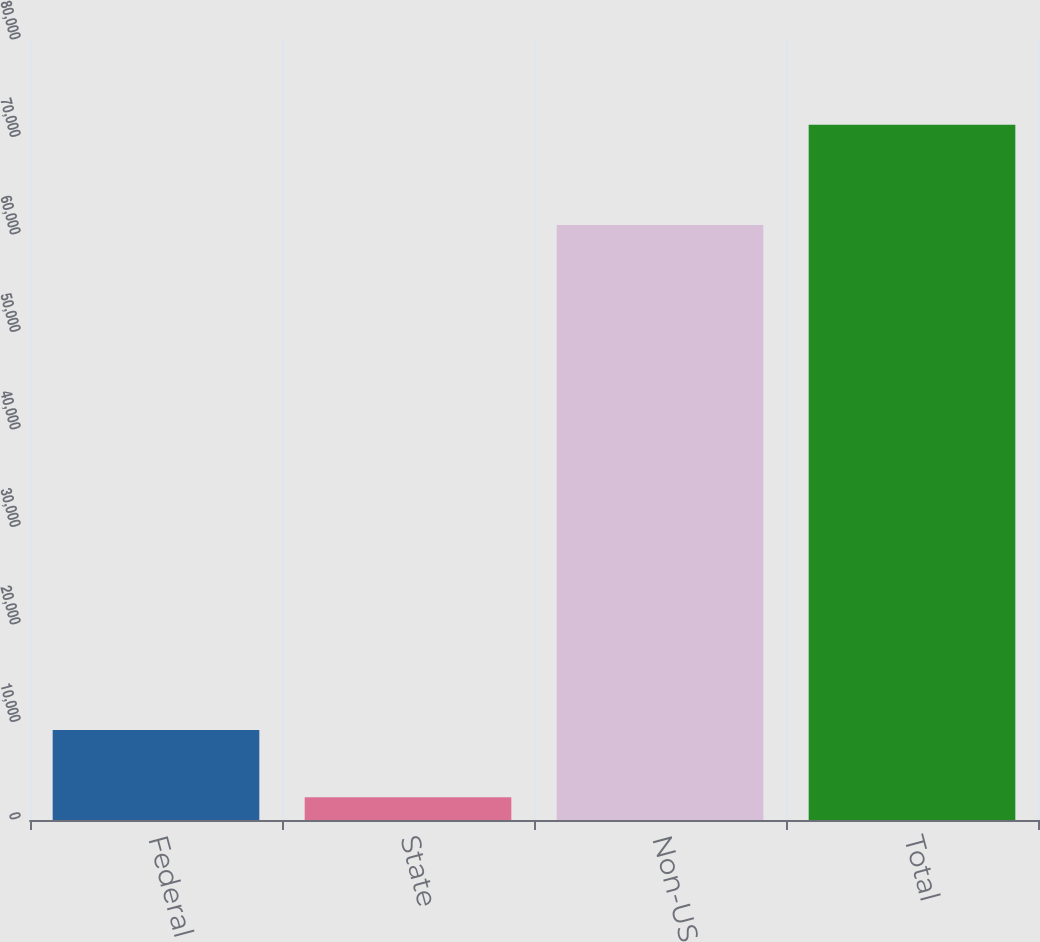Convert chart to OTSL. <chart><loc_0><loc_0><loc_500><loc_500><bar_chart><fcel>Federal<fcel>State<fcel>Non-US<fcel>Total<nl><fcel>9241.6<fcel>2345<fcel>61028<fcel>71311<nl></chart> 